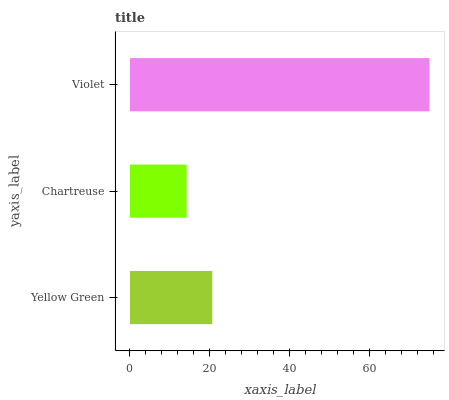Is Chartreuse the minimum?
Answer yes or no. Yes. Is Violet the maximum?
Answer yes or no. Yes. Is Violet the minimum?
Answer yes or no. No. Is Chartreuse the maximum?
Answer yes or no. No. Is Violet greater than Chartreuse?
Answer yes or no. Yes. Is Chartreuse less than Violet?
Answer yes or no. Yes. Is Chartreuse greater than Violet?
Answer yes or no. No. Is Violet less than Chartreuse?
Answer yes or no. No. Is Yellow Green the high median?
Answer yes or no. Yes. Is Yellow Green the low median?
Answer yes or no. Yes. Is Chartreuse the high median?
Answer yes or no. No. Is Chartreuse the low median?
Answer yes or no. No. 